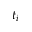<formula> <loc_0><loc_0><loc_500><loc_500>t _ { i }</formula> 